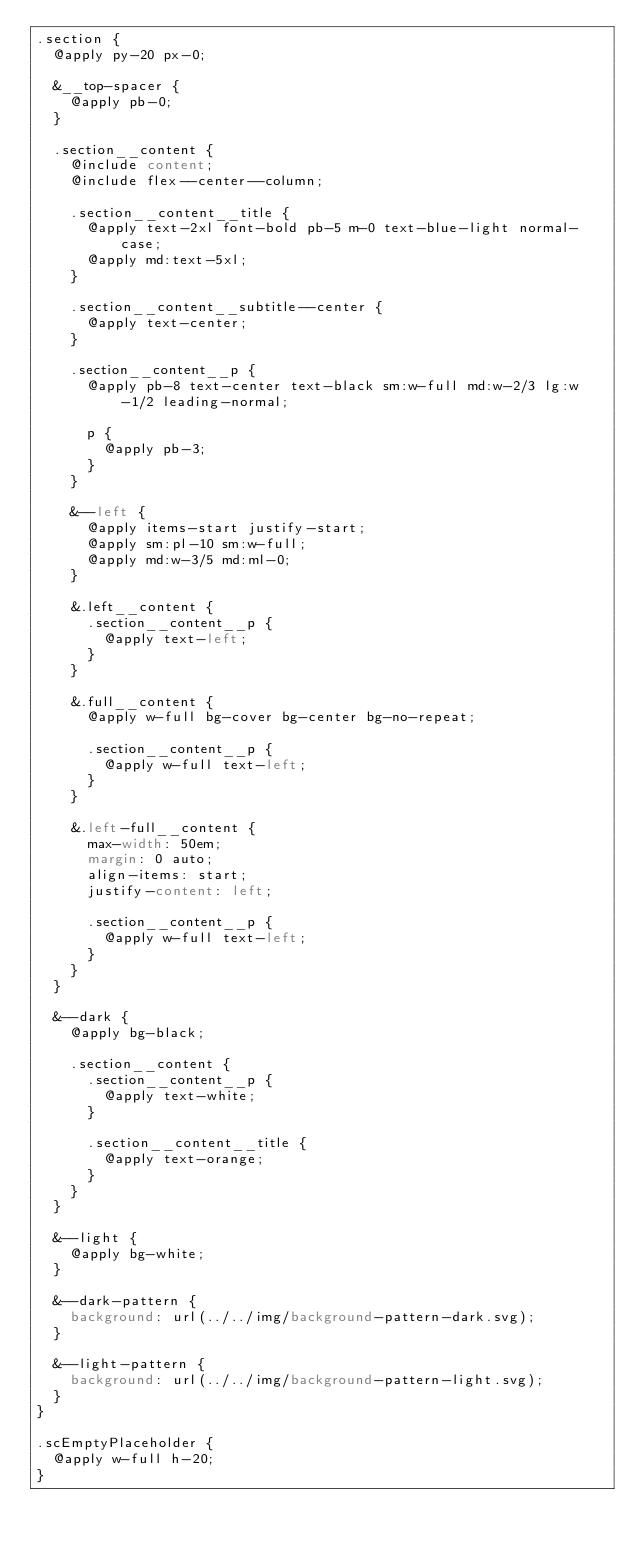Convert code to text. <code><loc_0><loc_0><loc_500><loc_500><_CSS_>.section {
  @apply py-20 px-0;

  &__top-spacer {
    @apply pb-0;
  }

  .section__content {
    @include content;
    @include flex--center--column;

    .section__content__title {
      @apply text-2xl font-bold pb-5 m-0 text-blue-light normal-case;
      @apply md:text-5xl;
    }

    .section__content__subtitle--center {
      @apply text-center;
    }

    .section__content__p {
      @apply pb-8 text-center text-black sm:w-full md:w-2/3 lg:w-1/2 leading-normal;

      p {
        @apply pb-3;
      }
    }

    &--left {
      @apply items-start justify-start;
      @apply sm:pl-10 sm:w-full;
      @apply md:w-3/5 md:ml-0;
    }

    &.left__content {
      .section__content__p {
        @apply text-left;
      }
    }

    &.full__content {
      @apply w-full bg-cover bg-center bg-no-repeat;

      .section__content__p {
        @apply w-full text-left;
      }
    }

    &.left-full__content {
      max-width: 50em;
      margin: 0 auto;
      align-items: start;
      justify-content: left;

      .section__content__p {
        @apply w-full text-left;
      }
    }
  }

  &--dark {
    @apply bg-black;

    .section__content {
      .section__content__p {
        @apply text-white;
      }

      .section__content__title {
        @apply text-orange;
      }
    }
  }

  &--light {
    @apply bg-white;
  }

  &--dark-pattern {
    background: url(../../img/background-pattern-dark.svg);
  }

  &--light-pattern {
    background: url(../../img/background-pattern-light.svg);
  }
}

.scEmptyPlaceholder {
  @apply w-full h-20;
}
</code> 